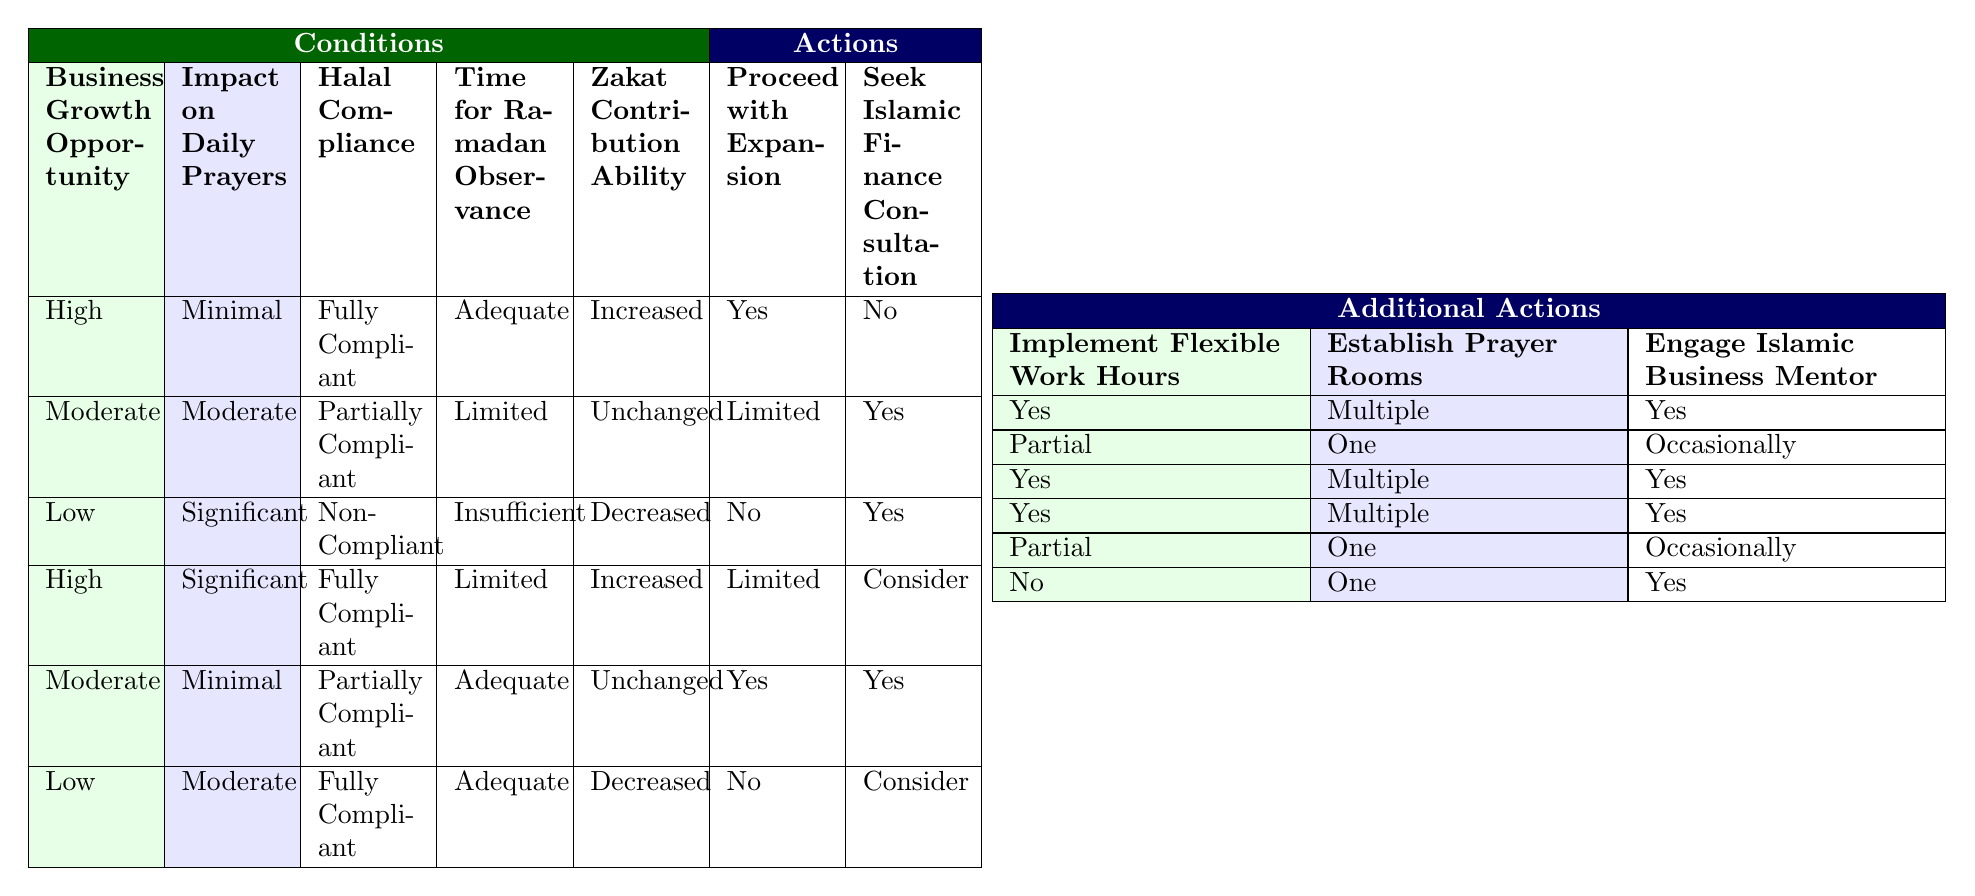What action is recommended if the business growth opportunity is high, impact on daily prayers is minimal, and halal compliance is fully compliant? According to the first row of the table where the conditions are "High," "Minimal," and "Fully Compliant," the recommended actions are to proceed with expansion (Yes), not seek Islamic finance consultation (No), implement flexible work hours (Yes), establish multiple prayer rooms (Multiple), and engage an Islamic business mentor (Yes).
Answer: Yes If the business growth opportunity is moderate, and the impact on daily prayers is moderate, what is the recommendation regarding establishing prayer rooms? In the second row where the conditions are "Moderate" and "Moderate," the action regarding prayer rooms is to establish just one prayer room (One).
Answer: One What is the zakat contribution ability when the business growth opportunity is low, and the impact on daily prayers is moderate? Referring to the last row where "Low" is paired with "Moderate" impact on prayers, the zakat contribution ability is decreased (Decreased).
Answer: Decreased Is there a recommendation to proceed with expansion if the halal compliance is non-compliant and the time for Ramadan observance is insufficient? In the third row, where halal compliance is non-compliant and the time for Ramadan observance is insufficient, the recommendation is not to proceed with expansion (No).
Answer: No According to the table, what is the average recommendation for seeking Islamic finance consultation across all conditions? The options for seeking Islamic finance consultation are "No," "Yes," and "Consider." Counting occurrences: "Yes" appears 4 times, "Consider" 3 times, and "No" 3 times. The total number of recommendations is 10. The average indicates a tendency towards "Yes."
Answer: Yes 